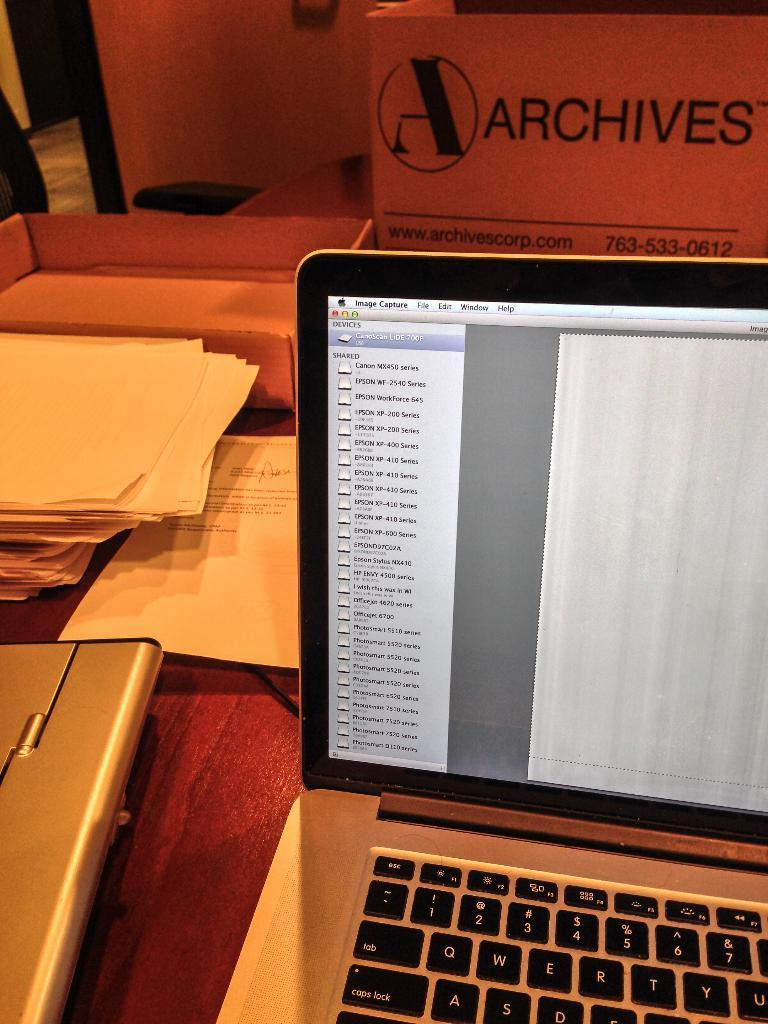Provide a one-sentence caption for the provided image. A laptop computer is open and a box that says Archives is in front of it. 